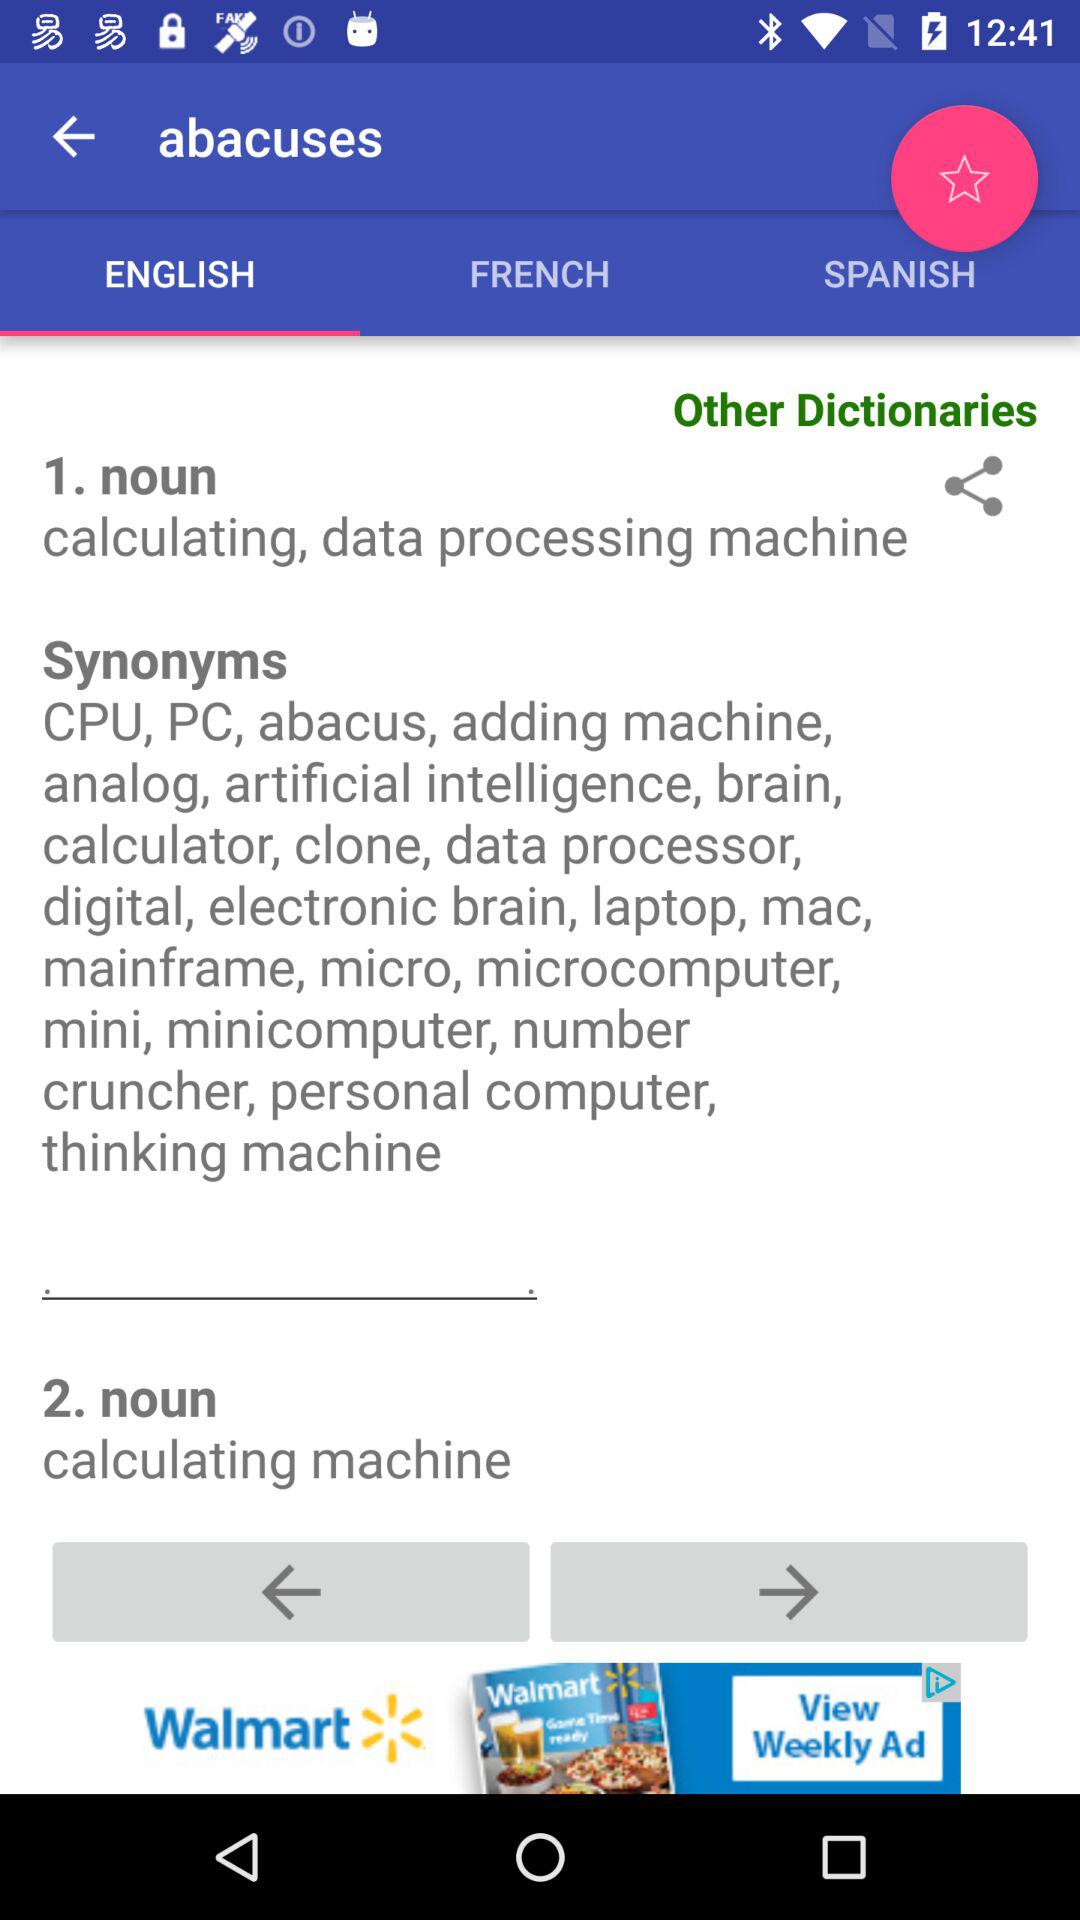What are the synonyms? The synonyms are CPU, PC, abacus, adding machine, analog, artificial intelligence, brain, calculator, clone, data processor, digital, electronic brain, laptop, mac, mainframe, micro, microcomputer, mini, minicomputer, number cruncher, personal computer and thinking machine. 